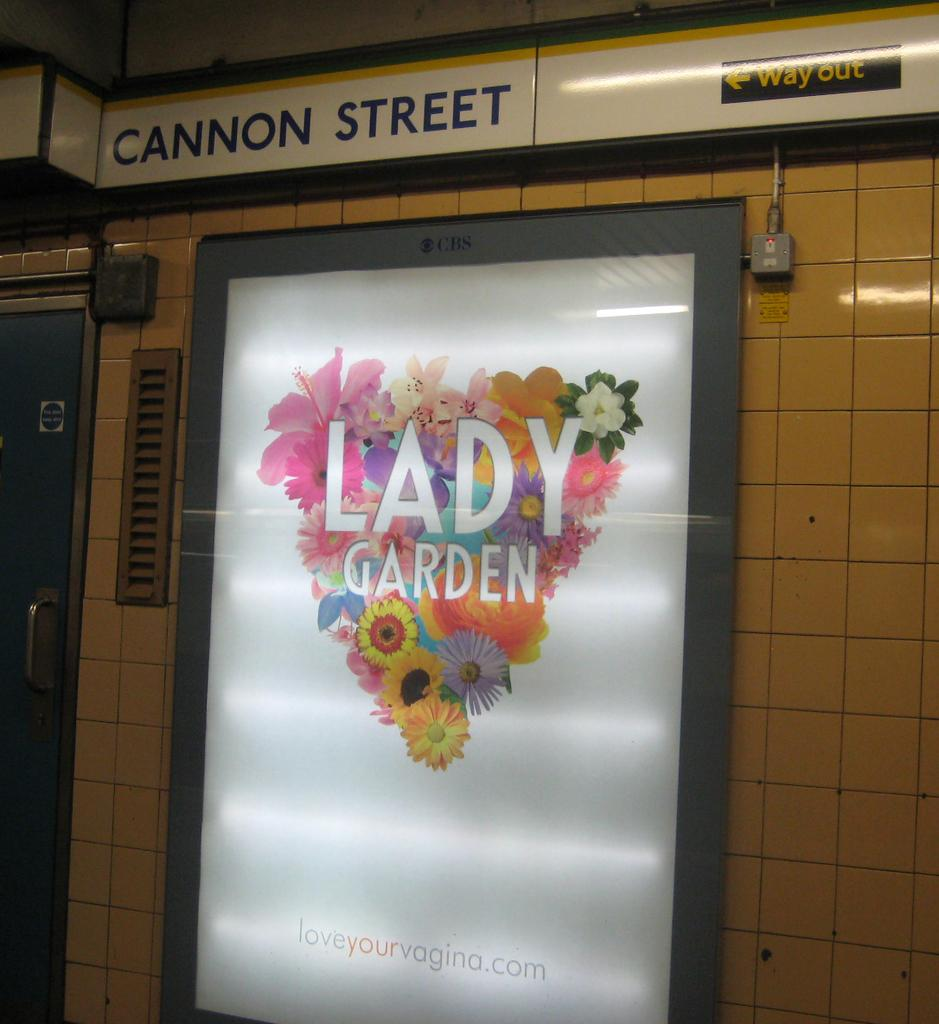What is present on the board in the image? There is text written on the board in the image. What can be seen on the left side of the image? There is a door on the left side of the image. Where is additional text located in the image? There is text written on the wall at the top of the image. Who is the writer of the text on the wall in the image? There is no information provided about the writer of the text in the image. What type of cast is visible in the image? There is no cast present in the image. 